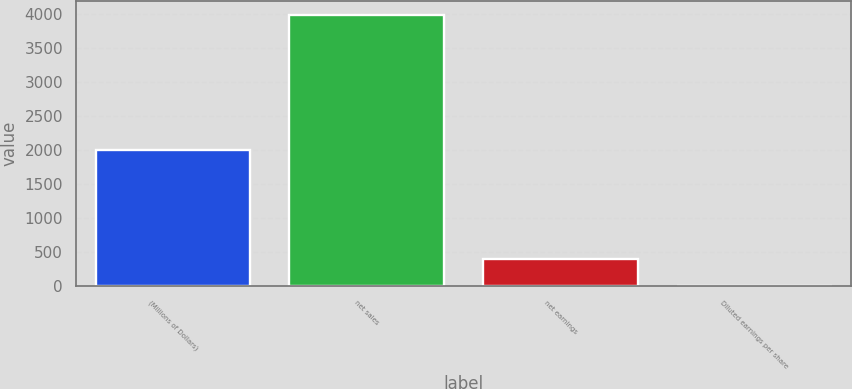Convert chart. <chart><loc_0><loc_0><loc_500><loc_500><bar_chart><fcel>(Millions of Dollars)<fcel>net sales<fcel>net earnings<fcel>Diluted earnings per share<nl><fcel>2005<fcel>3986.9<fcel>401.94<fcel>3.61<nl></chart> 